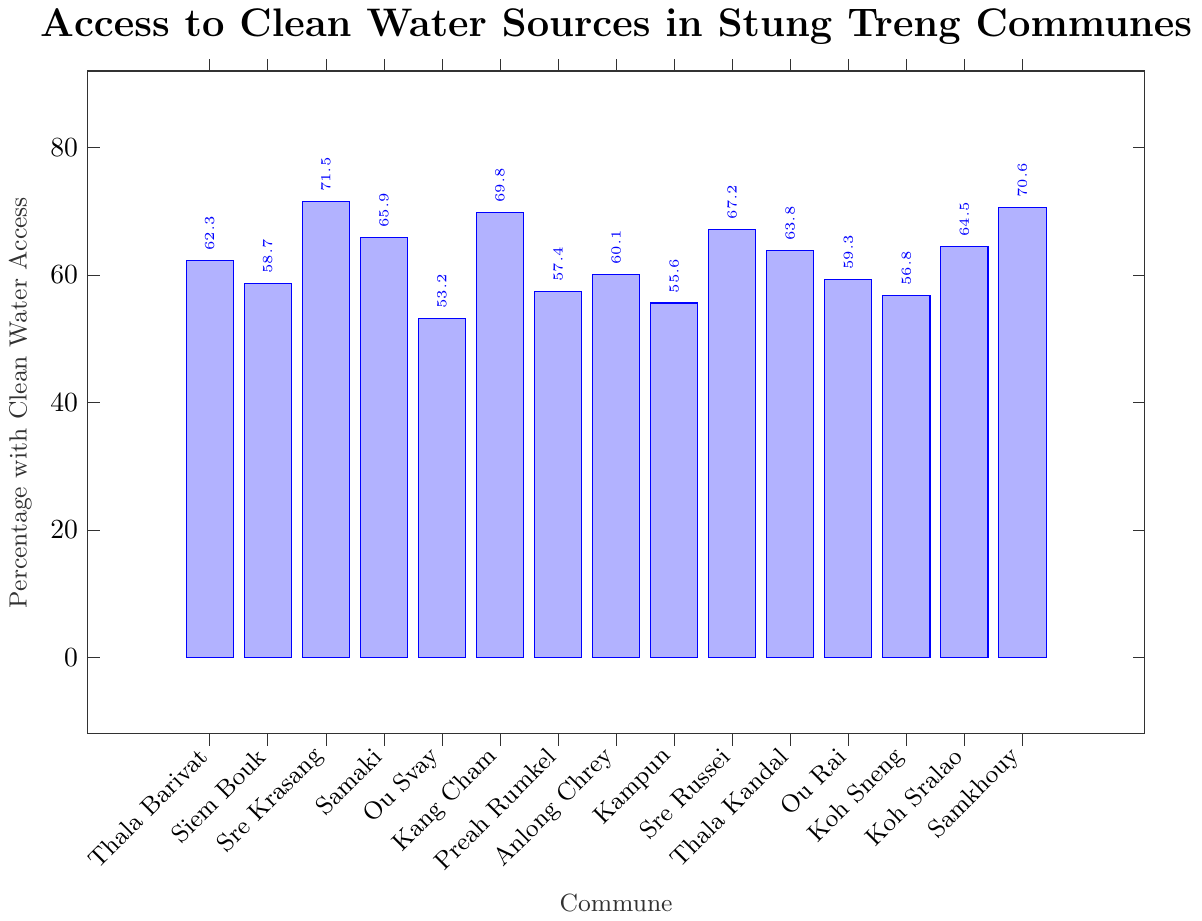What's the commune with the highest percentage of access to clean water? First, identify the tallest bar by its height. The tallest bar corresponds to Sre Krasang with a value of 71.5%.
Answer: Sre Krasang Which commune has the lowest percentage of access to clean water? Locate the shortest bar on the chart. The shortest bar corresponds to Ou Svay with a percentage of 53.2%.
Answer: Ou Svay What is the difference in percentage of access to clean water between Sre Krasang and Ou Svay? Sre Krasang has 71.5% whereas Ou Svay has 53.2%. Subtracting these gives 71.5 - 53.2 = 18.3.
Answer: 18.3% How many communes have at least 60% access to clean water? Count the number of bars that reach or exceed the 60% mark. These are Thala Barivat (62.3), Sre Krasang (71.5), Samaki (65.9), Kang Cham (69.8), Anlong Chrey (60.1), Sre Russei (67.2), Thala Kandal (63.8), Koh Sralao (64.5), and Samkhouy (70.6). Therefore, there are 9 communes.
Answer: 9 Which communes have percentages around the average (±5%)? First, calculate the average: (62.3 + 58.7 + 71.5 + 65.9 + 53.2 + 69.8 + 57.4 + 60.1 + 55.6 + 67.2 + 63.8 + 59.3 + 56.8 + 64.5 + 70.6) / 15 = 62.77. Communes around ±5% of the average are those within the range 57.77 to 67.77. These are Thala Barivat (62.3), Siem Bouk (58.7), Samaki (65.9), Preah Rumkel (57.4), Anlong Chrey (60.1), Sre Russei (67.2), Thala Kandal (63.8), Ou Rai (59.3), Koh Sneng (56.8), and Koh Sralao (64.5).
Answer: Thala Barivat, Siem Bouk, Samaki, Preah Rumkel, Anlong Chrey, Sre Russei, Thala Kandal, Ou Rai, Koh Sneng, Koh Sralao Which commune has a percentage closest to 65%? Locate the percentage values and find the closest to 65%. The closest value is Samaki with 65.9%.
Answer: Samaki What is the median percentage of access to clean water? Arrange the percentages in ascending order: 53.2, 55.6, 56.8, 57.4, 58.7, 59.3, 60.1, 62.3, 63.8, 64.5, 65.9, 67.2, 69.8, 70.6, 71.5. The median is the middle value in this ordered list, which is the 8th value, 62.3.
Answer: 62.3% Which communes have access percentages greater than 70%? Identify bars higher than the 70% mark. These are Sre Krasang (71.5) and Samkhouy (70.6).
Answer: Sre Krasang, Samkhouy What is the cumulative percentage of the top 3 communes? The top 3 percentages are Sre Krasang (71.5), Samkhouy (70.6), and Kang Cham (69.8). Summing these gives 71.5 + 70.6 + 69.8 = 211.9.
Answer: 211.9% What percentage does Thala Kandal have, and where does it rank among the communes? Thala Kandal has 63.8% access to clean water. Arrange the percentages in descending order: 71.5 (1st), 70.6 (2nd), 69.8 (3rd), 67.2 (4th), 65.9 (5th), 64.5 (6th), 63.8 (7th). Therefore, Thala Kandal ranks 7th.
Answer: 63.8%, 7th 